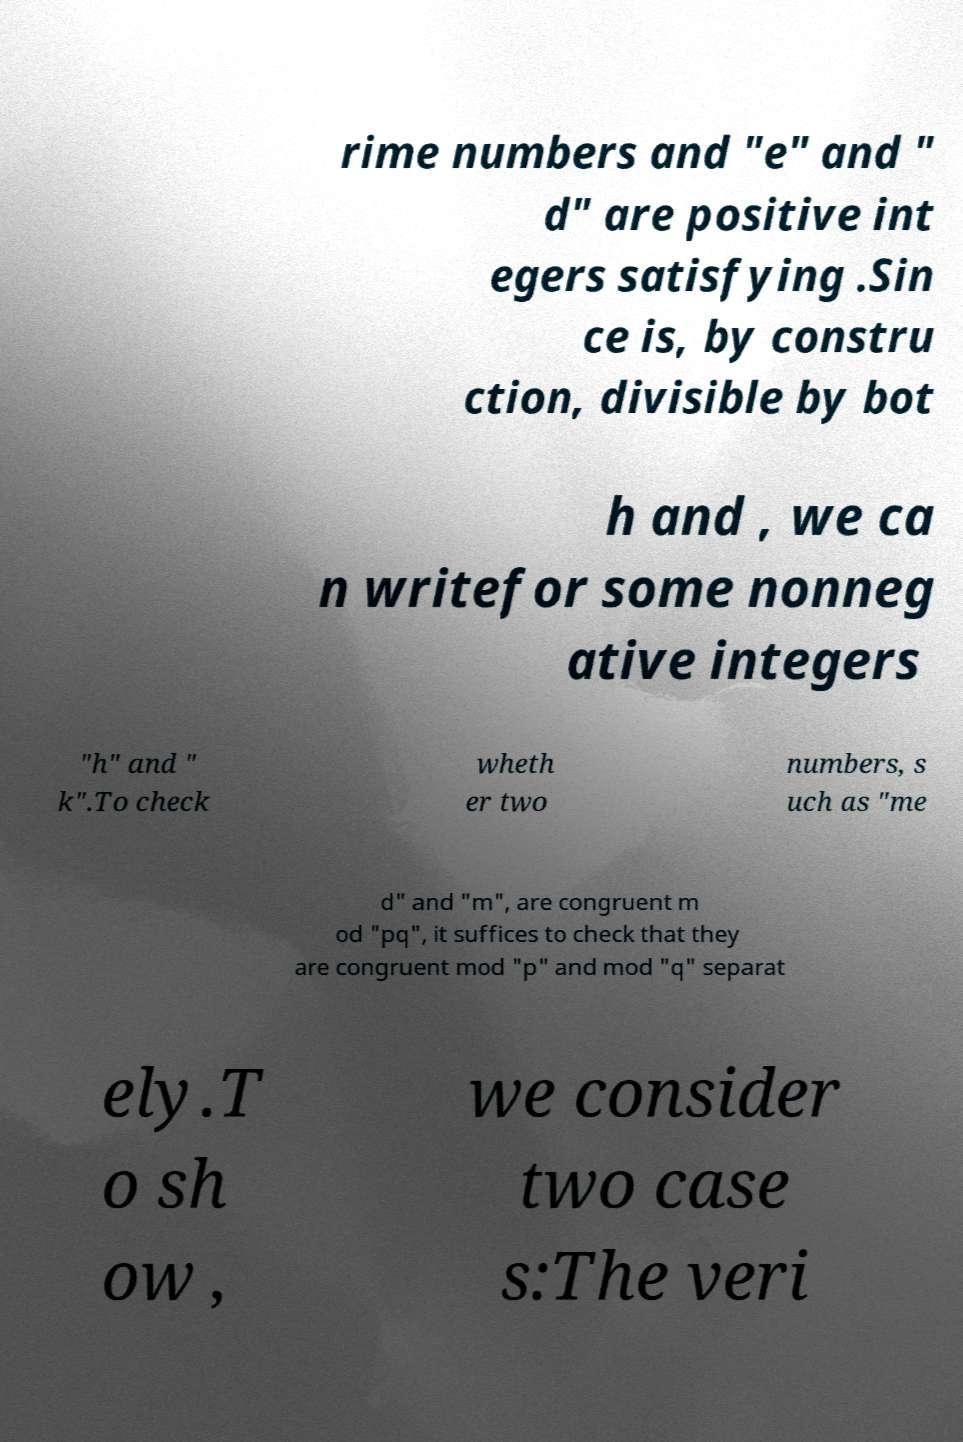There's text embedded in this image that I need extracted. Can you transcribe it verbatim? rime numbers and "e" and " d" are positive int egers satisfying .Sin ce is, by constru ction, divisible by bot h and , we ca n writefor some nonneg ative integers "h" and " k".To check wheth er two numbers, s uch as "me d" and "m", are congruent m od "pq", it suffices to check that they are congruent mod "p" and mod "q" separat ely.T o sh ow , we consider two case s:The veri 